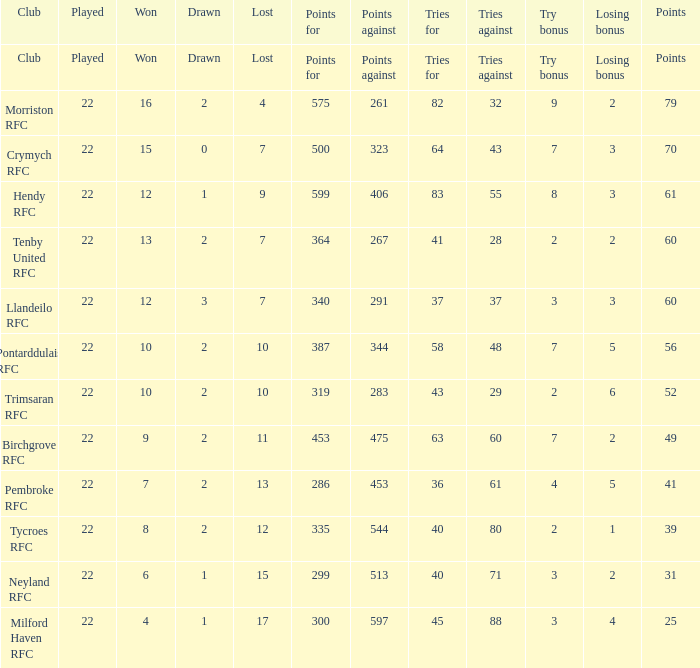How many points against with endeavors for being 43? 1.0. 